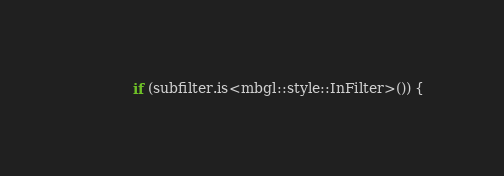Convert code to text. <code><loc_0><loc_0><loc_500><loc_500><_ObjectiveC_>            if (subfilter.is<mbgl::style::InFilter>()) {</code> 